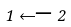Convert formula to latex. <formula><loc_0><loc_0><loc_500><loc_500>1 \longleftarrow 2</formula> 